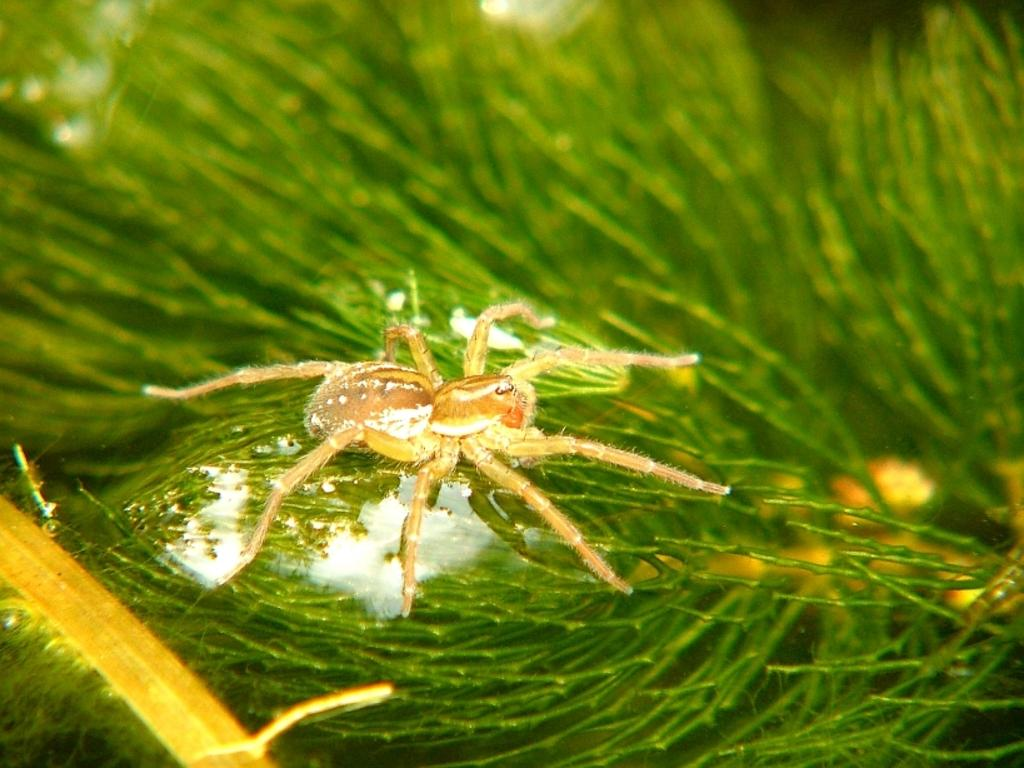What type of creature can be seen in the image? There is an insect in the image. What is the insect resting on in the image? The insect is on a green surface. What type of headwear is the insect wearing in the image? There is no headwear visible on the insect in the image. What type of land is the insect standing on in the image? The image does not show the insect standing on land; it is on a green surface, which could be a leaf or another object. 